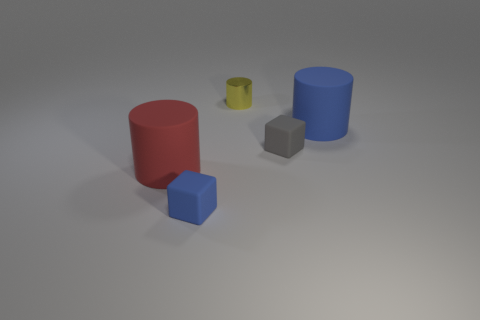Subtract all brown cylinders. Subtract all blue balls. How many cylinders are left? 3 Add 2 red matte cylinders. How many objects exist? 7 Subtract all cylinders. How many objects are left? 2 Add 2 yellow shiny cylinders. How many yellow shiny cylinders exist? 3 Subtract 0 purple balls. How many objects are left? 5 Subtract all yellow things. Subtract all small yellow shiny cylinders. How many objects are left? 3 Add 2 metallic cylinders. How many metallic cylinders are left? 3 